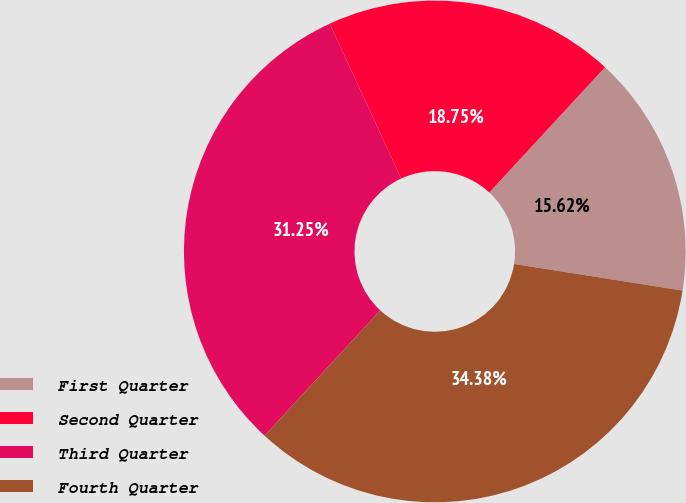<chart> <loc_0><loc_0><loc_500><loc_500><pie_chart><fcel>First Quarter<fcel>Second Quarter<fcel>Third Quarter<fcel>Fourth Quarter<nl><fcel>15.62%<fcel>18.75%<fcel>31.25%<fcel>34.38%<nl></chart> 